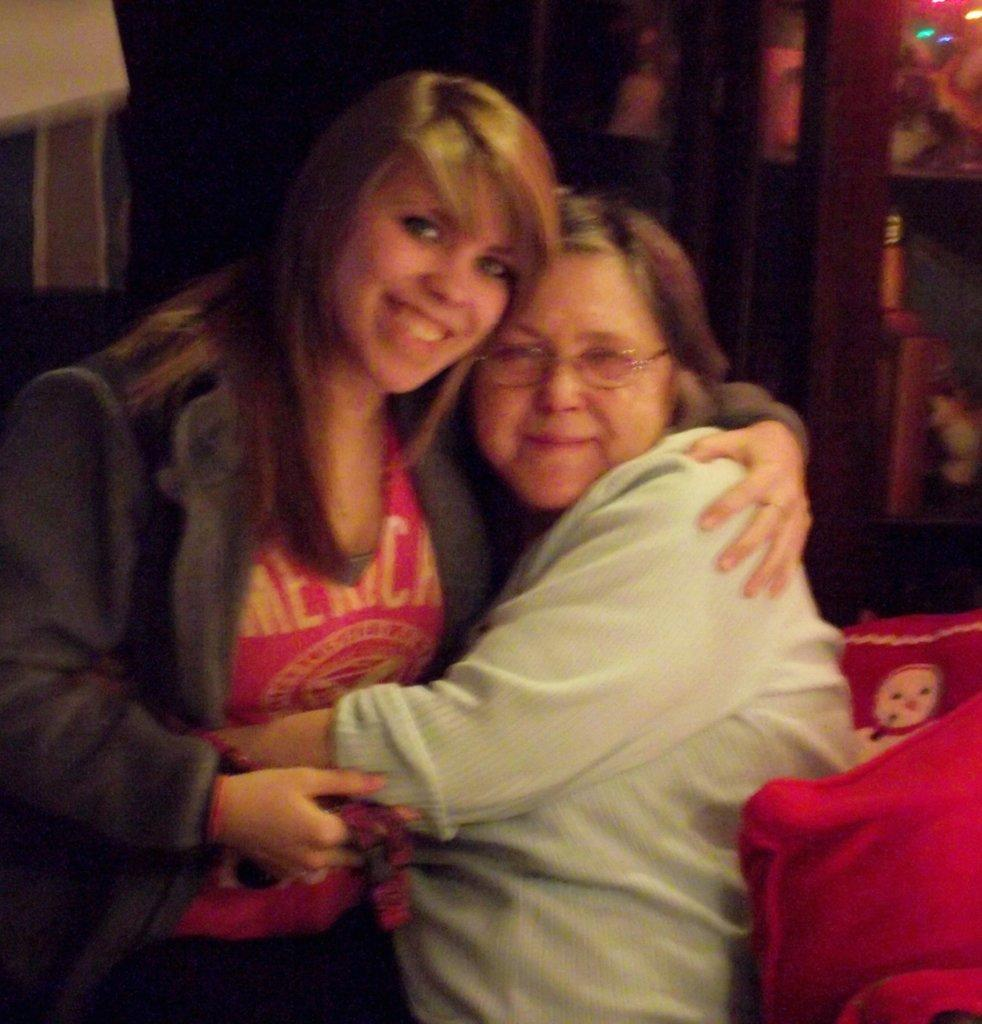How many people are in the image? There are two persons in the image. What is located behind the persons? There is a wall visible behind the persons. What can be seen on the right side of the image? There are objects on the right side of the image. What type of skin condition is visible on the persons in the image? There is no indication of any skin condition visible on the persons in the image. What is the purpose of the yoke in the image? There is no yoke present in the image. 